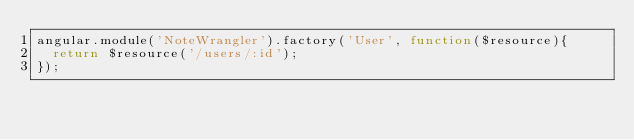<code> <loc_0><loc_0><loc_500><loc_500><_JavaScript_>angular.module('NoteWrangler').factory('User', function($resource){
  return $resource('/users/:id');
});</code> 